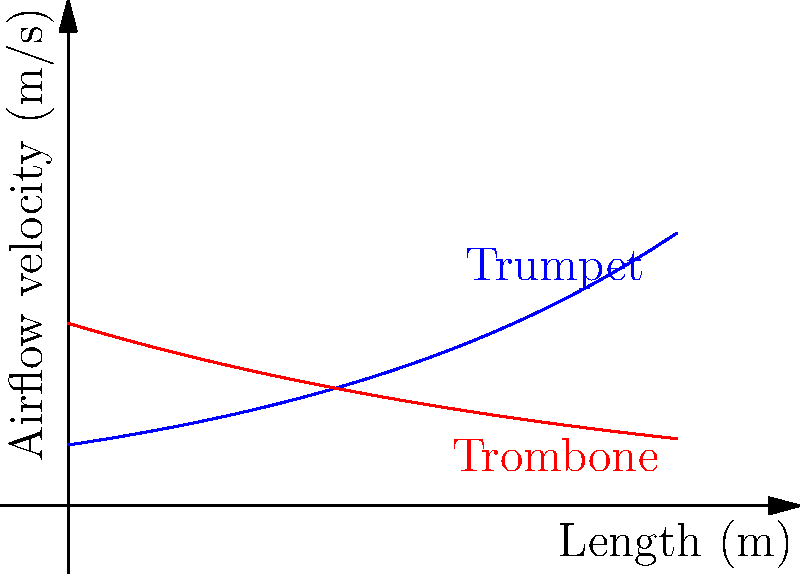Your punk band is considering adding brass instruments to your sound. Looking at the graph showing airflow velocity through a trumpet and trombone, which instrument would require more lung power to play at its maximum length? To determine which instrument requires more lung power at its maximum length, we need to compare the airflow velocities at the rightmost point of the graph (representing the maximum length). Let's break it down:

1. The blue line represents the trumpet, and the red line represents the trombone.
2. The x-axis shows the length of the instrument, and the y-axis shows the airflow velocity.
3. At the maximum length (rightmost point on the graph):
   - The trumpet's airflow velocity is increasing exponentially.
   - The trombone's airflow velocity is decreasing exponentially.
4. At the 5-meter mark (maximum length shown):
   - The trumpet's airflow velocity is significantly higher than the trombone's.
5. Higher airflow velocity requires more lung power to maintain.

Therefore, based on the graph, the trumpet would require more lung power to play at its maximum length compared to the trombone.
Answer: Trumpet 